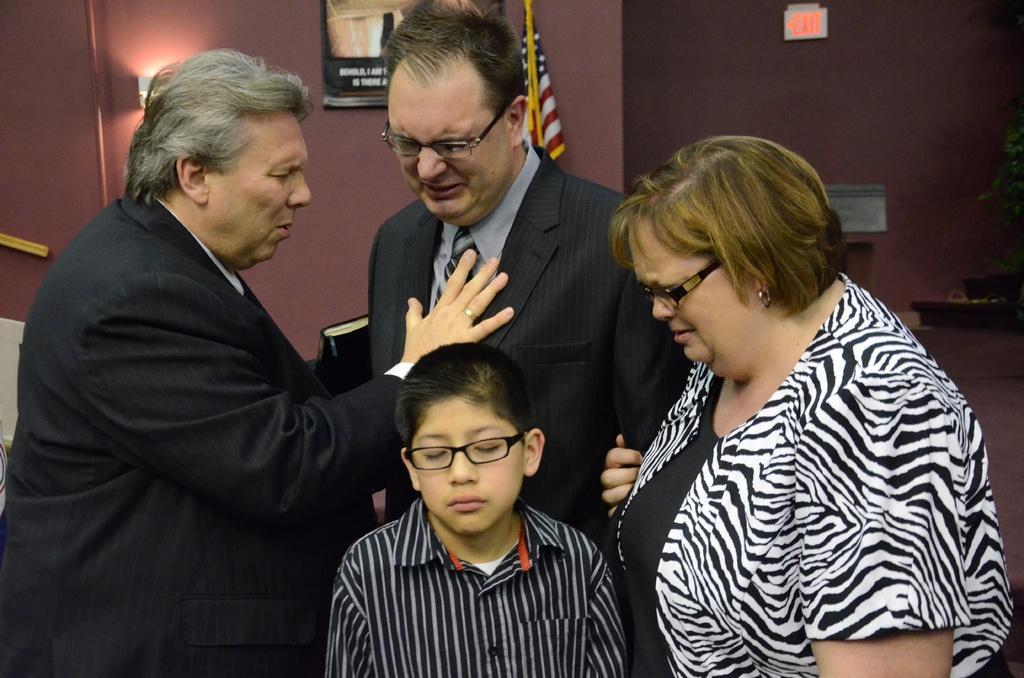Describe this image in one or two sentences. In this image I can see the group of people with blue, black and ash color dresses. In the background I can see the flag and the boards to the wall. 